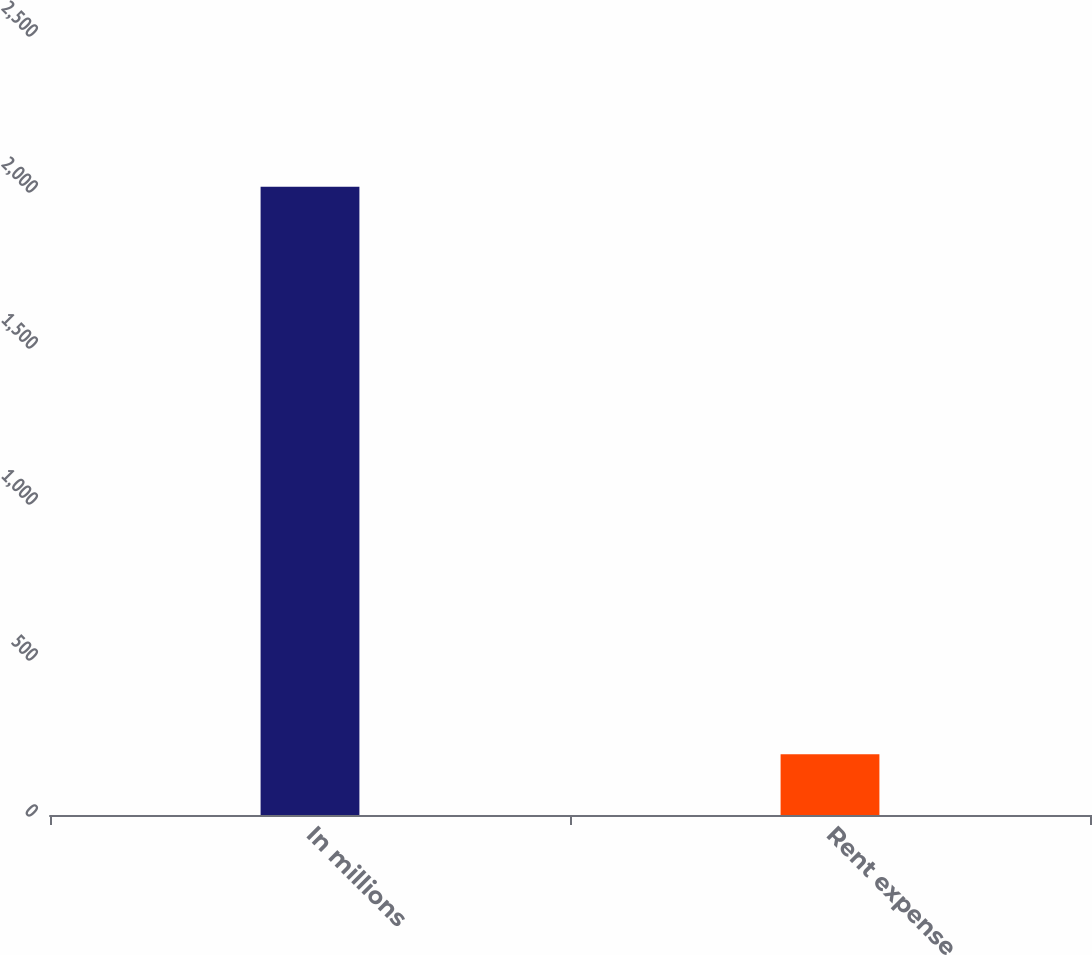Convert chart to OTSL. <chart><loc_0><loc_0><loc_500><loc_500><bar_chart><fcel>In millions<fcel>Rent expense<nl><fcel>2014<fcel>195<nl></chart> 